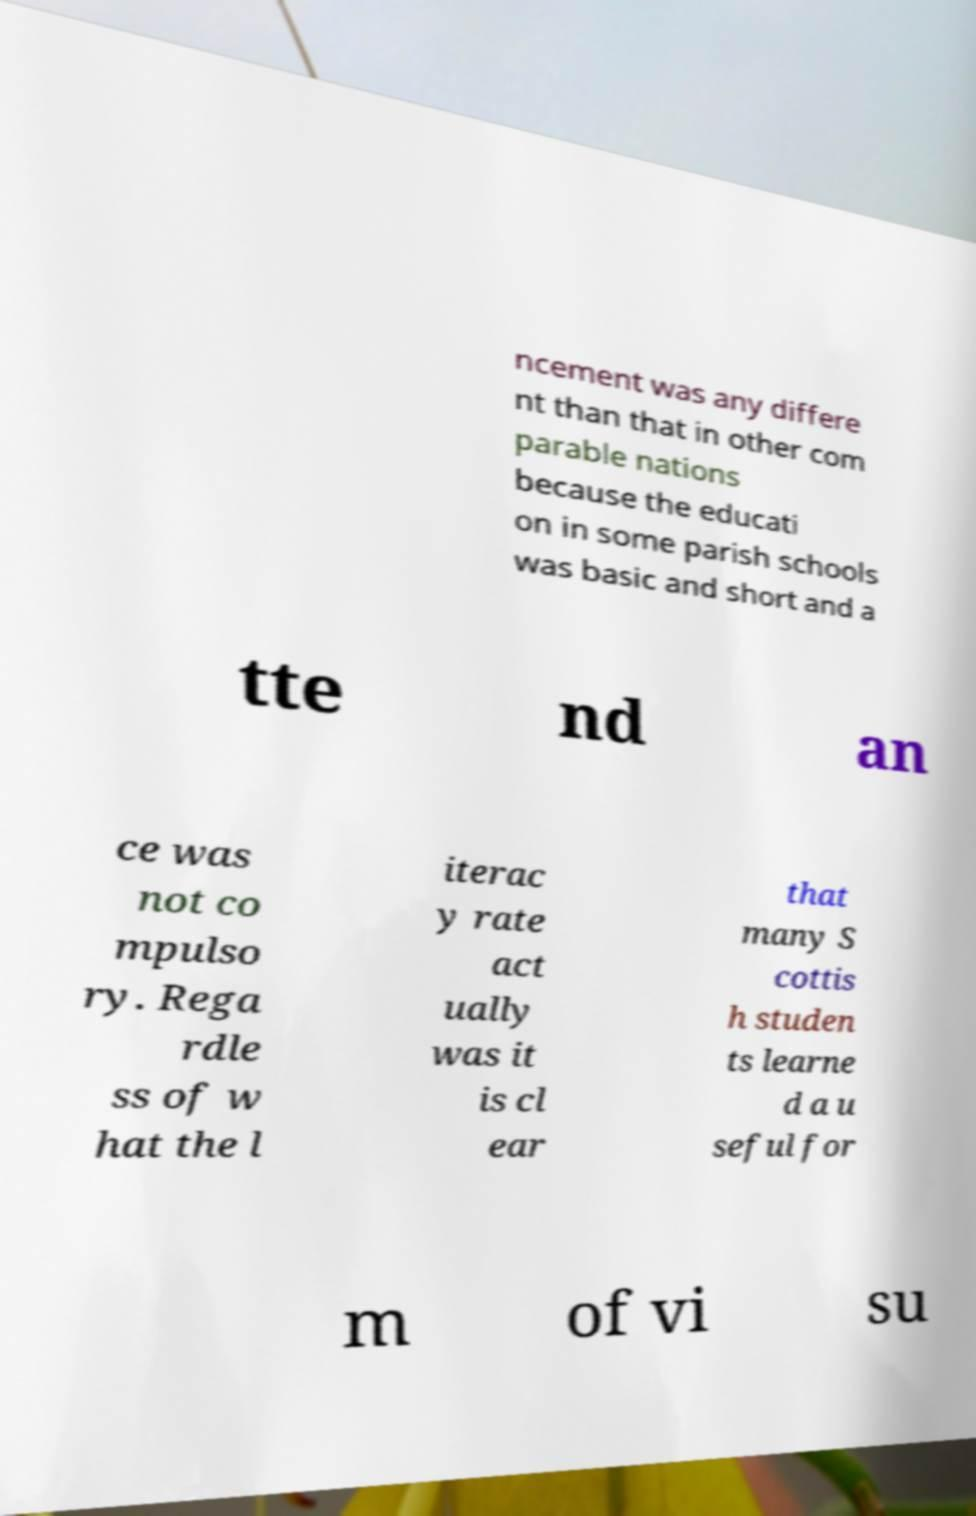For documentation purposes, I need the text within this image transcribed. Could you provide that? ncement was any differe nt than that in other com parable nations because the educati on in some parish schools was basic and short and a tte nd an ce was not co mpulso ry. Rega rdle ss of w hat the l iterac y rate act ually was it is cl ear that many S cottis h studen ts learne d a u seful for m of vi su 